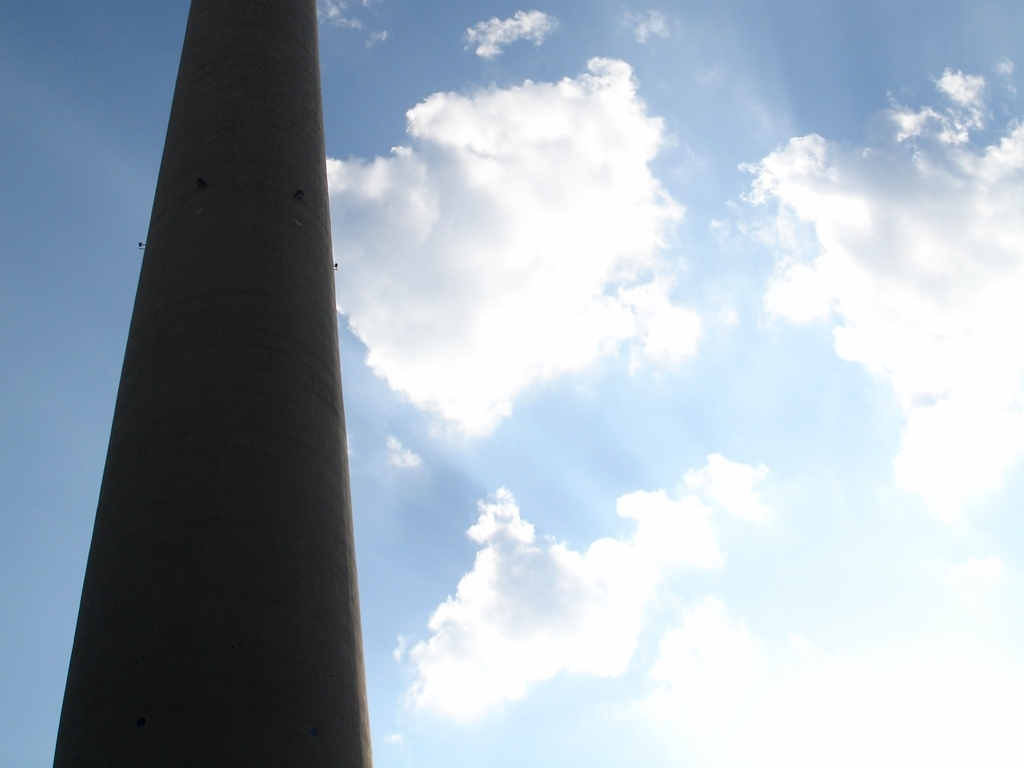Is there anything about the image that suggests the time of day it might be? The image shows the structure from a low angle with the sky in the background, where the brightness level and shadowing on the structure suggest it could be midday. However, the exact time is difficult to ascertain without more contextual clues or understanding the geographic location and direction of the sun. 